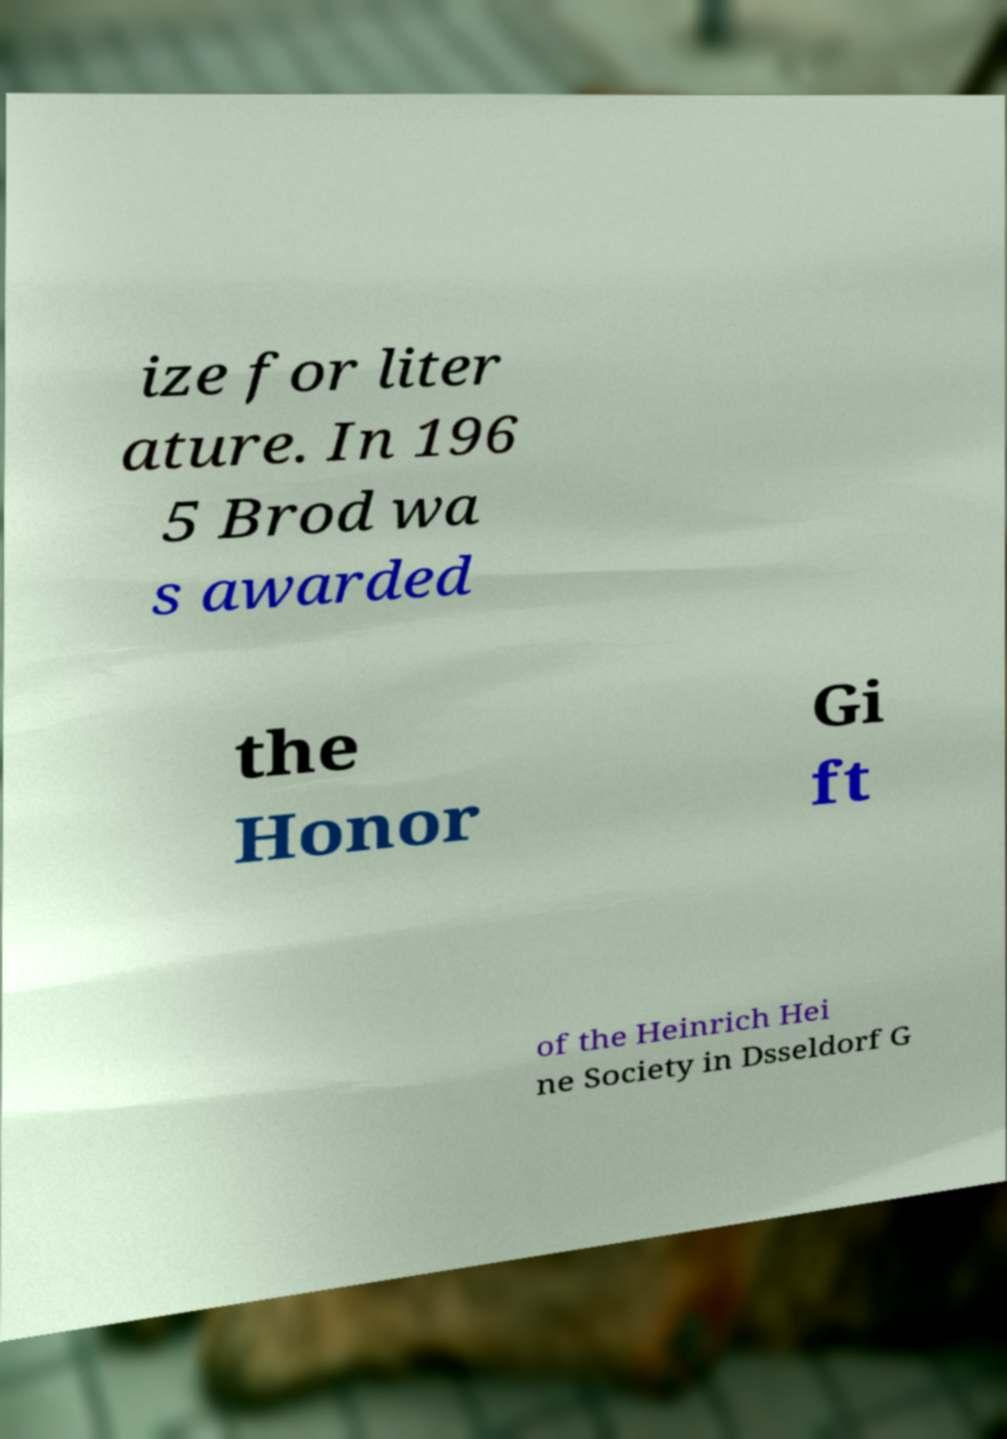Please identify and transcribe the text found in this image. ize for liter ature. In 196 5 Brod wa s awarded the Honor Gi ft of the Heinrich Hei ne Society in Dsseldorf G 